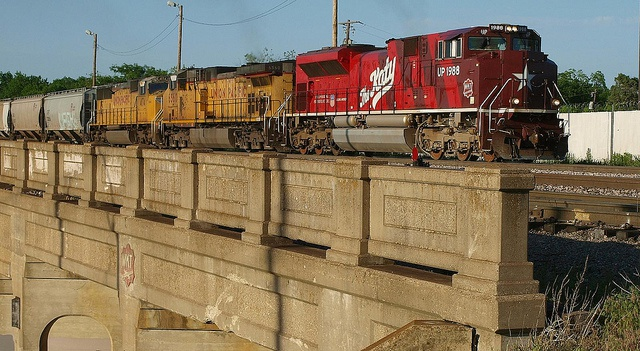Describe the objects in this image and their specific colors. I can see a train in darkgray, black, maroon, and gray tones in this image. 